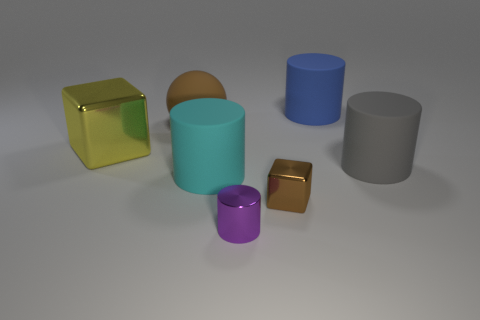There is a shiny cube that is right of the yellow shiny object; how many yellow metal blocks are behind it?
Your response must be concise. 1. What is the color of the small shiny thing that is the same shape as the large gray thing?
Offer a terse response. Purple. Is the big ball made of the same material as the blue cylinder?
Offer a terse response. Yes. What number of balls are brown metal objects or tiny shiny objects?
Provide a short and direct response. 0. There is a metallic cube on the right side of the metal block behind the block in front of the big cyan thing; how big is it?
Your response must be concise. Small. The purple object that is the same shape as the cyan object is what size?
Make the answer very short. Small. What number of brown metal things are on the right side of the brown rubber object?
Give a very brief answer. 1. There is a metal cube that is to the right of the big brown sphere; is it the same color as the matte ball?
Your answer should be very brief. Yes. How many brown things are large shiny cubes or small things?
Provide a short and direct response. 1. The big matte cylinder to the right of the matte cylinder behind the large ball is what color?
Keep it short and to the point. Gray. 